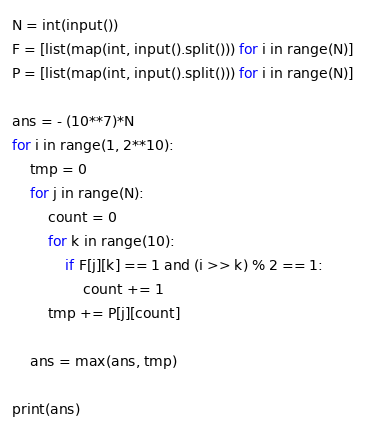Convert code to text. <code><loc_0><loc_0><loc_500><loc_500><_Python_>N = int(input())
F = [list(map(int, input().split())) for i in range(N)]
P = [list(map(int, input().split())) for i in range(N)]

ans = - (10**7)*N
for i in range(1, 2**10):
    tmp = 0
    for j in range(N):
        count = 0
        for k in range(10):
            if F[j][k] == 1 and (i >> k) % 2 == 1:
                count += 1
        tmp += P[j][count]

    ans = max(ans, tmp)

print(ans)
</code> 